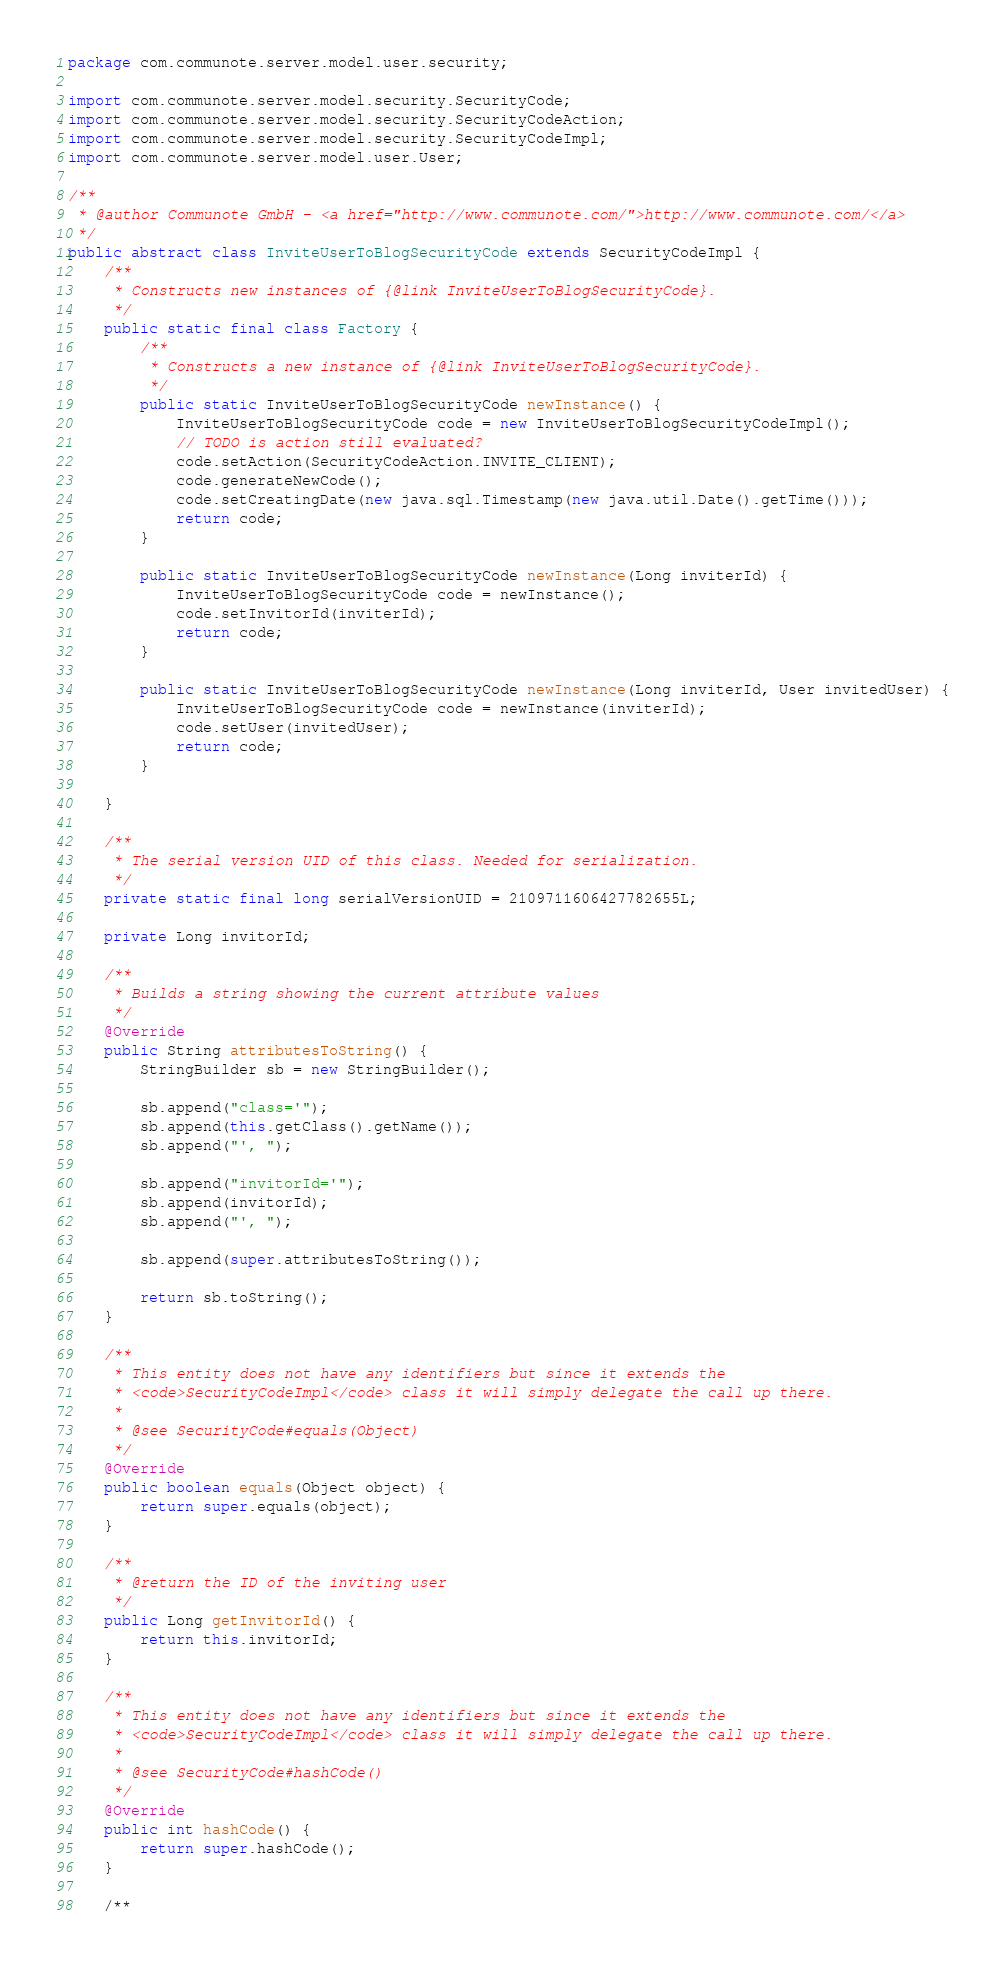<code> <loc_0><loc_0><loc_500><loc_500><_Java_>package com.communote.server.model.user.security;

import com.communote.server.model.security.SecurityCode;
import com.communote.server.model.security.SecurityCodeAction;
import com.communote.server.model.security.SecurityCodeImpl;
import com.communote.server.model.user.User;

/**
 * @author Communote GmbH - <a href="http://www.communote.com/">http://www.communote.com/</a>
 */
public abstract class InviteUserToBlogSecurityCode extends SecurityCodeImpl {
    /**
     * Constructs new instances of {@link InviteUserToBlogSecurityCode}.
     */
    public static final class Factory {
        /**
         * Constructs a new instance of {@link InviteUserToBlogSecurityCode}.
         */
        public static InviteUserToBlogSecurityCode newInstance() {
            InviteUserToBlogSecurityCode code = new InviteUserToBlogSecurityCodeImpl();
            // TODO is action still evaluated?
            code.setAction(SecurityCodeAction.INVITE_CLIENT);
            code.generateNewCode();
            code.setCreatingDate(new java.sql.Timestamp(new java.util.Date().getTime()));
            return code;
        }

        public static InviteUserToBlogSecurityCode newInstance(Long inviterId) {
            InviteUserToBlogSecurityCode code = newInstance();
            code.setInvitorId(inviterId);
            return code;
        }

        public static InviteUserToBlogSecurityCode newInstance(Long inviterId, User invitedUser) {
            InviteUserToBlogSecurityCode code = newInstance(inviterId);
            code.setUser(invitedUser);
            return code;
        }

    }

    /**
     * The serial version UID of this class. Needed for serialization.
     */
    private static final long serialVersionUID = 2109711606427782655L;

    private Long invitorId;

    /**
     * Builds a string showing the current attribute values
     */
    @Override
    public String attributesToString() {
        StringBuilder sb = new StringBuilder();

        sb.append("class='");
        sb.append(this.getClass().getName());
        sb.append("', ");

        sb.append("invitorId='");
        sb.append(invitorId);
        sb.append("', ");

        sb.append(super.attributesToString());

        return sb.toString();
    }

    /**
     * This entity does not have any identifiers but since it extends the
     * <code>SecurityCodeImpl</code> class it will simply delegate the call up there.
     *
     * @see SecurityCode#equals(Object)
     */
    @Override
    public boolean equals(Object object) {
        return super.equals(object);
    }

    /**
     * @return the ID of the inviting user
     */
    public Long getInvitorId() {
        return this.invitorId;
    }

    /**
     * This entity does not have any identifiers but since it extends the
     * <code>SecurityCodeImpl</code> class it will simply delegate the call up there.
     *
     * @see SecurityCode#hashCode()
     */
    @Override
    public int hashCode() {
        return super.hashCode();
    }

    /**</code> 